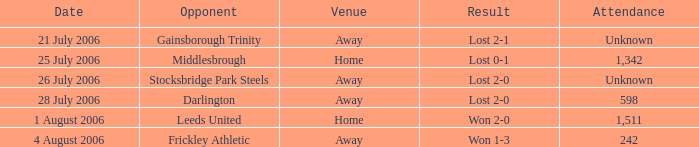What is the attendance rate for the Middlesbrough opponent? 1342.0. 